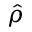<formula> <loc_0><loc_0><loc_500><loc_500>\hat { \rho }</formula> 